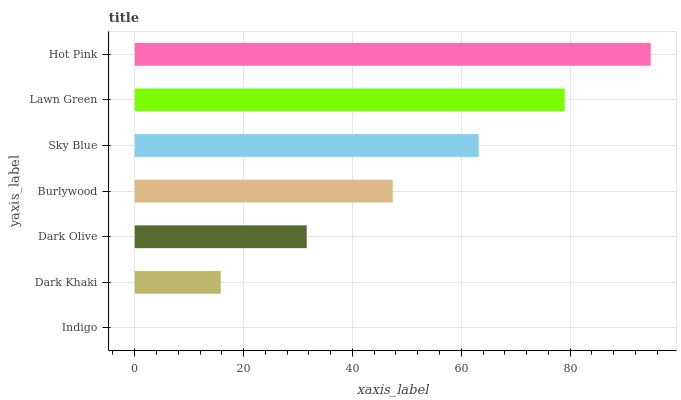Is Indigo the minimum?
Answer yes or no. Yes. Is Hot Pink the maximum?
Answer yes or no. Yes. Is Dark Khaki the minimum?
Answer yes or no. No. Is Dark Khaki the maximum?
Answer yes or no. No. Is Dark Khaki greater than Indigo?
Answer yes or no. Yes. Is Indigo less than Dark Khaki?
Answer yes or no. Yes. Is Indigo greater than Dark Khaki?
Answer yes or no. No. Is Dark Khaki less than Indigo?
Answer yes or no. No. Is Burlywood the high median?
Answer yes or no. Yes. Is Burlywood the low median?
Answer yes or no. Yes. Is Hot Pink the high median?
Answer yes or no. No. Is Dark Olive the low median?
Answer yes or no. No. 